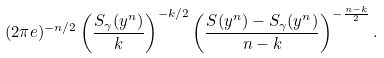<formula> <loc_0><loc_0><loc_500><loc_500>( 2 \pi e ) ^ { - n / 2 } \left ( \frac { S _ { \gamma } ( y ^ { n } ) } { k } \right ) ^ { - k / 2 } \left ( \frac { S ( y ^ { n } ) - S _ { \gamma } ( y ^ { n } ) } { n - k } \right ) ^ { - \frac { n - k } { 2 } } .</formula> 